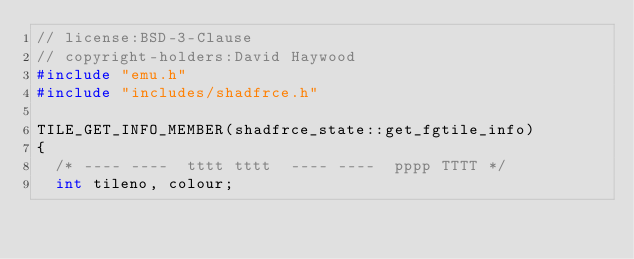<code> <loc_0><loc_0><loc_500><loc_500><_C++_>// license:BSD-3-Clause
// copyright-holders:David Haywood
#include "emu.h"
#include "includes/shadfrce.h"

TILE_GET_INFO_MEMBER(shadfrce_state::get_fgtile_info)
{
	/* ---- ----  tttt tttt  ---- ----  pppp TTTT */
	int tileno, colour;
</code> 